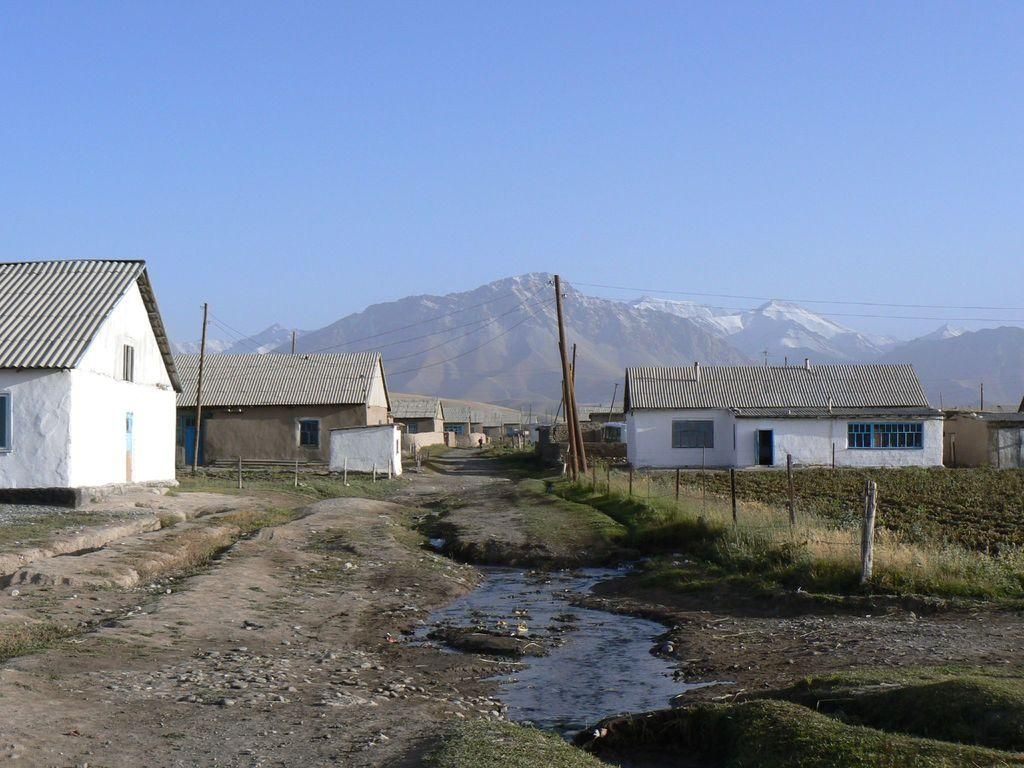What type of structures can be seen in the image? There are houses in the image. What architectural features are present in the image? There are walls, windows, and doors in the image. What other elements can be seen in the image? There are poles, plants, grass, water, and stones in the image. What can be seen in the background of the image? The background of the image includes hills and the sky. What type of egg can be seen rolling down the hill in the image? There is no egg present in the image, and therefore no such activity can be observed. What type of thrill can be experienced by the people in the image? The image does not depict any people, so it is impossible to determine what type of thrill they might experience. 